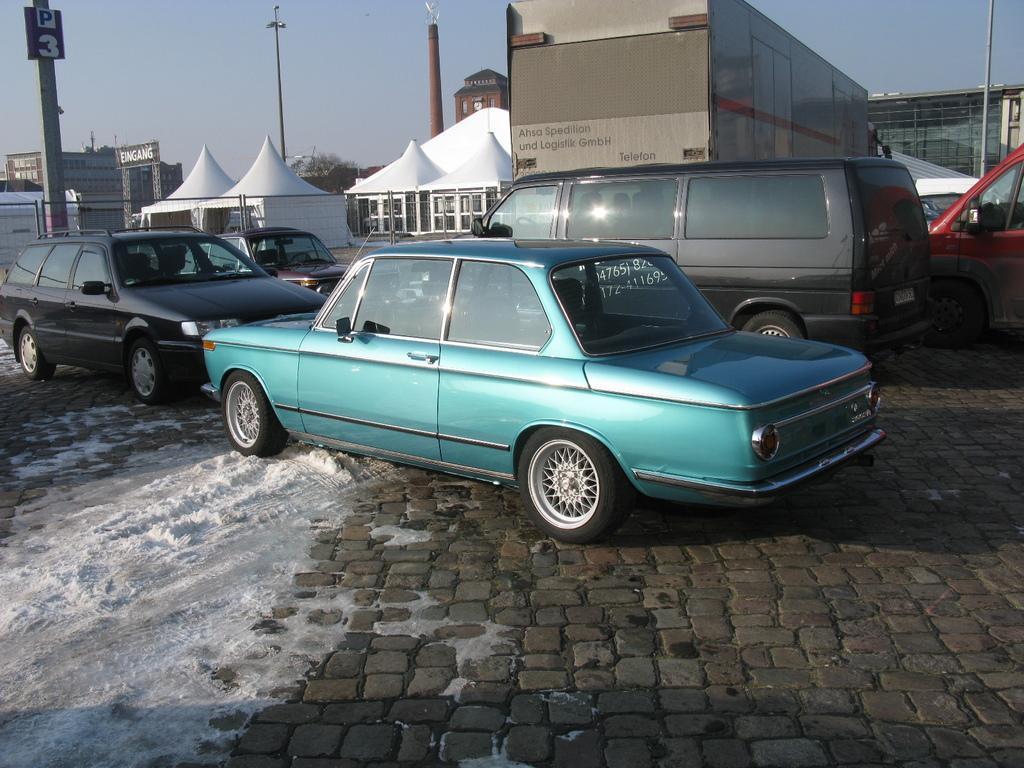Describe this image in one or two sentences. Here we can see vehicles on the road and there is a container vehicle. On the left we can see snow on the ground. In the background there are tents,poles,buildings,windows,glass doors,hoardings,poles,trees and sky. 